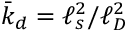Convert formula to latex. <formula><loc_0><loc_0><loc_500><loc_500>\bar { k } _ { d } = \ell _ { s } ^ { 2 } / \ell _ { D } ^ { 2 }</formula> 